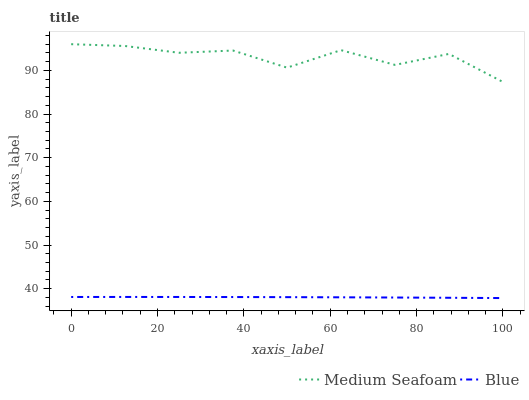Does Medium Seafoam have the minimum area under the curve?
Answer yes or no. No. Is Medium Seafoam the smoothest?
Answer yes or no. No. Does Medium Seafoam have the lowest value?
Answer yes or no. No. Is Blue less than Medium Seafoam?
Answer yes or no. Yes. Is Medium Seafoam greater than Blue?
Answer yes or no. Yes. Does Blue intersect Medium Seafoam?
Answer yes or no. No. 